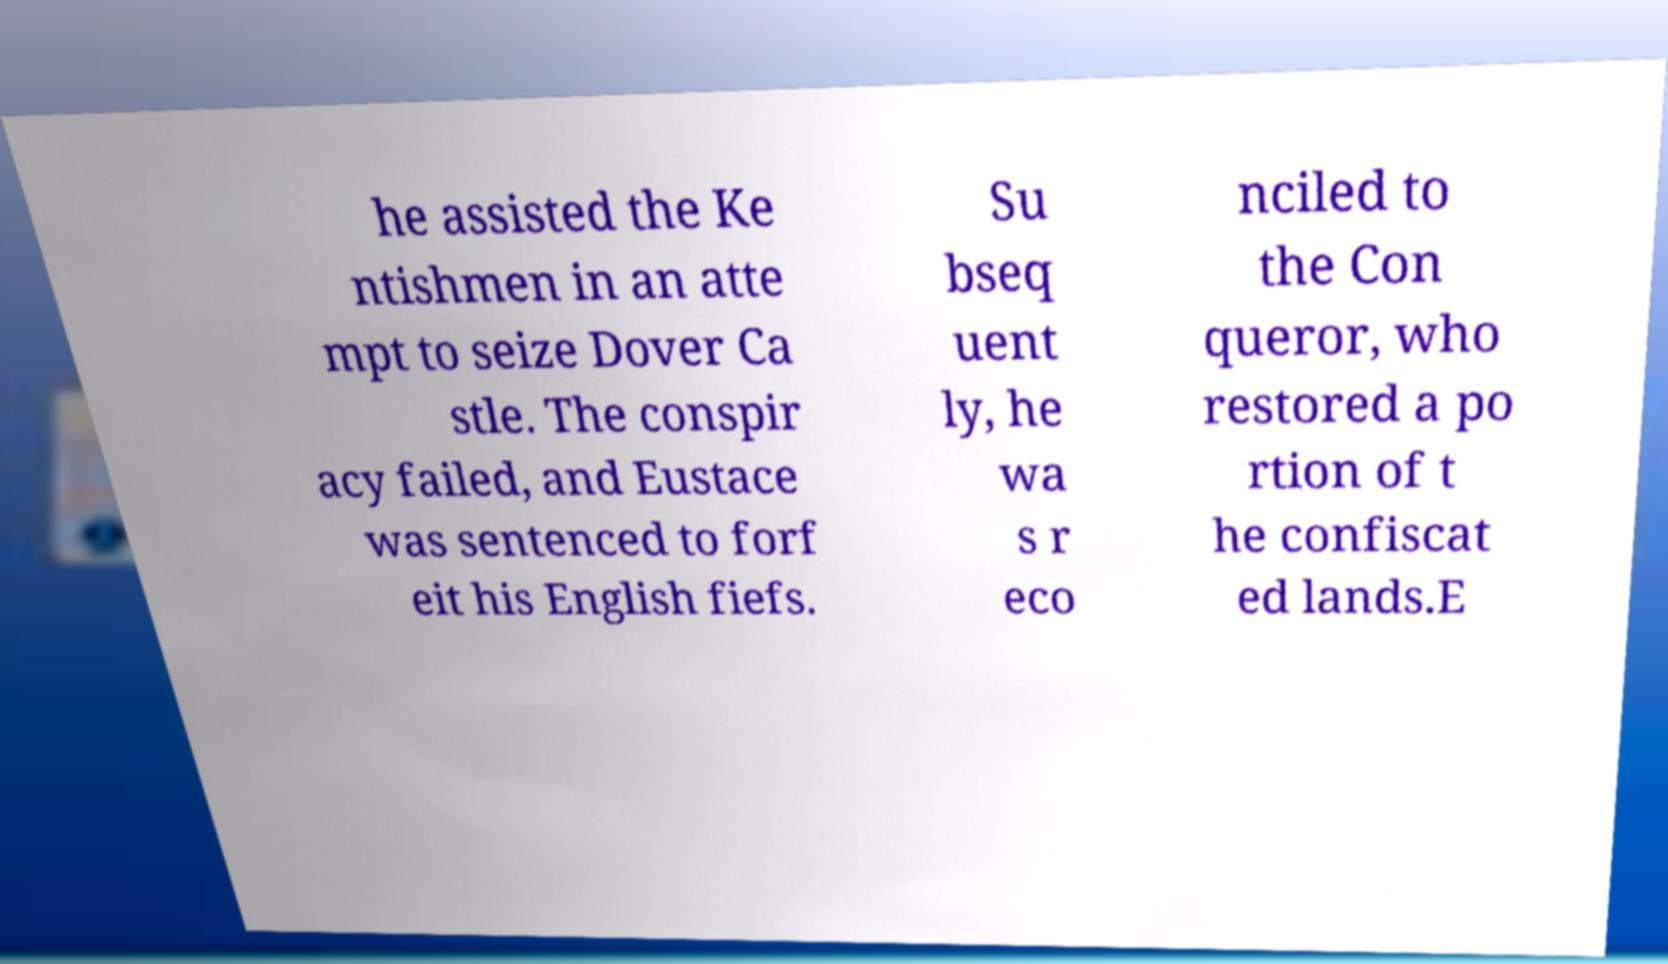I need the written content from this picture converted into text. Can you do that? he assisted the Ke ntishmen in an atte mpt to seize Dover Ca stle. The conspir acy failed, and Eustace was sentenced to forf eit his English fiefs. Su bseq uent ly, he wa s r eco nciled to the Con queror, who restored a po rtion of t he confiscat ed lands.E 